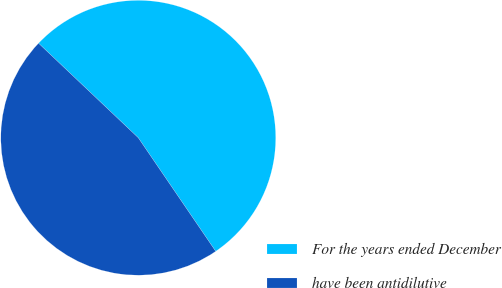Convert chart to OTSL. <chart><loc_0><loc_0><loc_500><loc_500><pie_chart><fcel>For the years ended December<fcel>have been antidilutive<nl><fcel>53.4%<fcel>46.6%<nl></chart> 